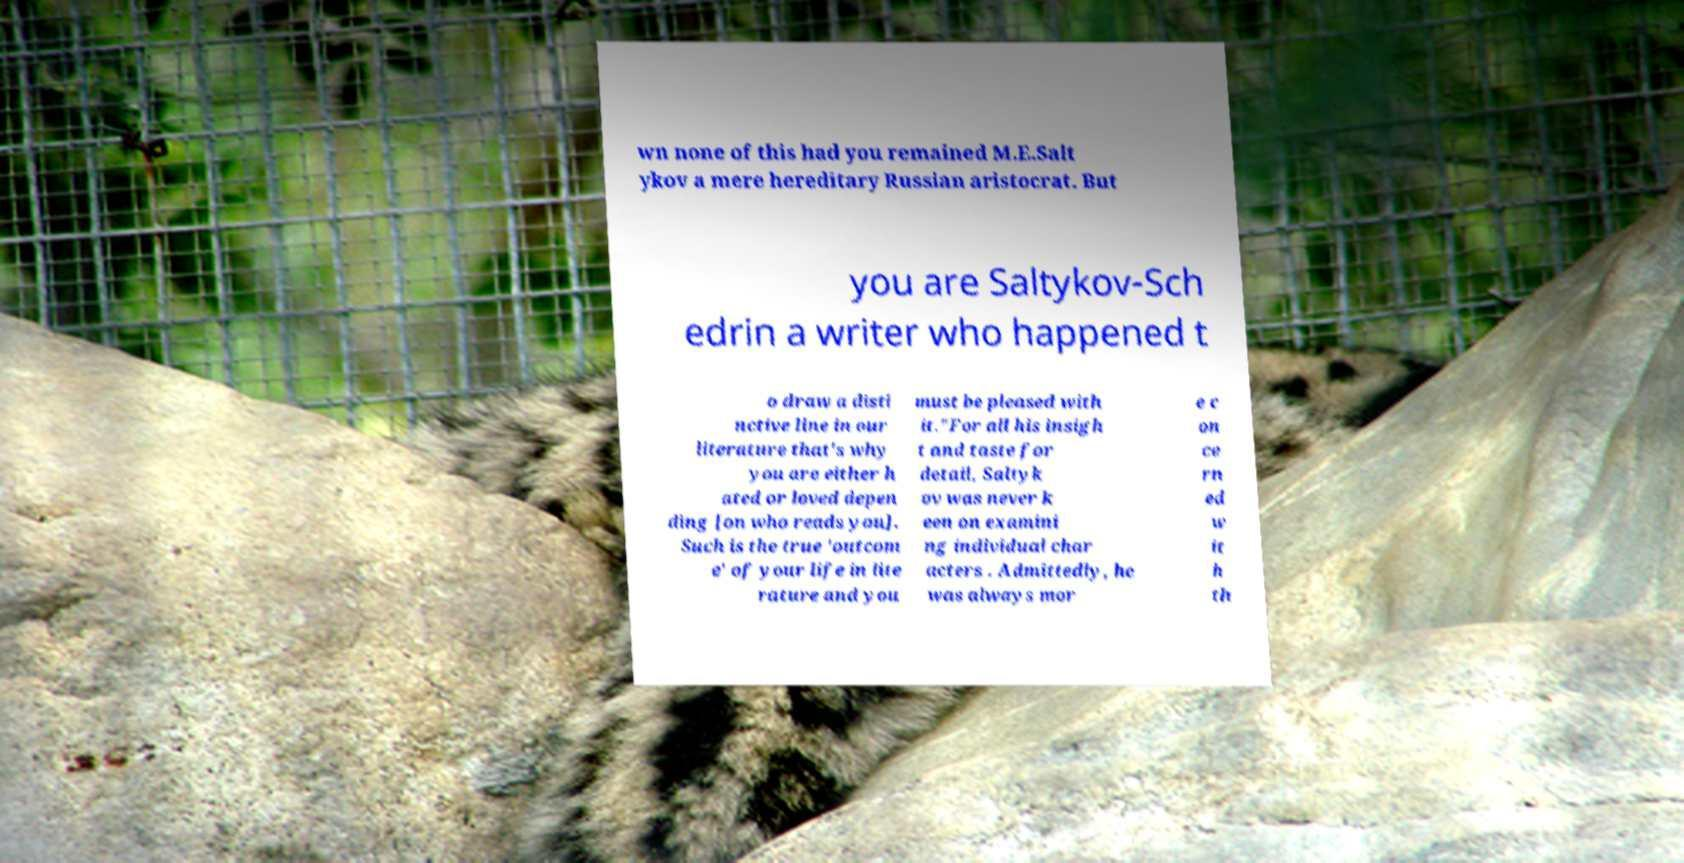Can you read and provide the text displayed in the image?This photo seems to have some interesting text. Can you extract and type it out for me? wn none of this had you remained M.E.Salt ykov a mere hereditary Russian aristocrat. But you are Saltykov-Sch edrin a writer who happened t o draw a disti nctive line in our literature that's why you are either h ated or loved depen ding [on who reads you]. Such is the true 'outcom e' of your life in lite rature and you must be pleased with it."For all his insigh t and taste for detail, Saltyk ov was never k een on examini ng individual char acters . Admittedly, he was always mor e c on ce rn ed w it h th 